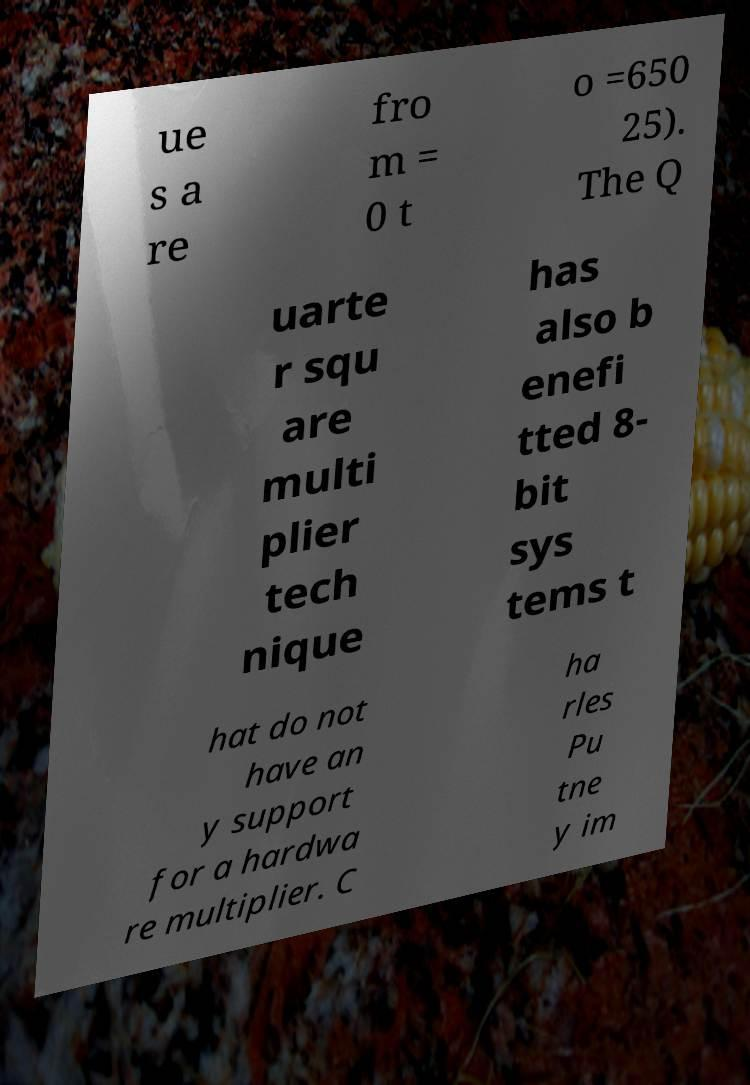Could you extract and type out the text from this image? ue s a re fro m = 0 t o =650 25). The Q uarte r squ are multi plier tech nique has also b enefi tted 8- bit sys tems t hat do not have an y support for a hardwa re multiplier. C ha rles Pu tne y im 